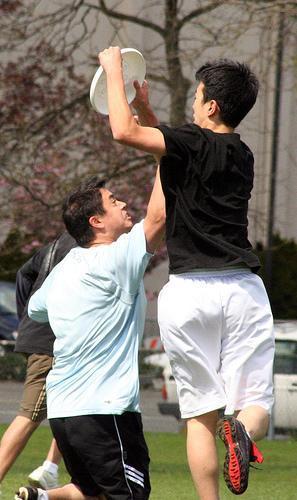How many people are there?
Give a very brief answer. 3. How many feet are visible?
Give a very brief answer. 3. 